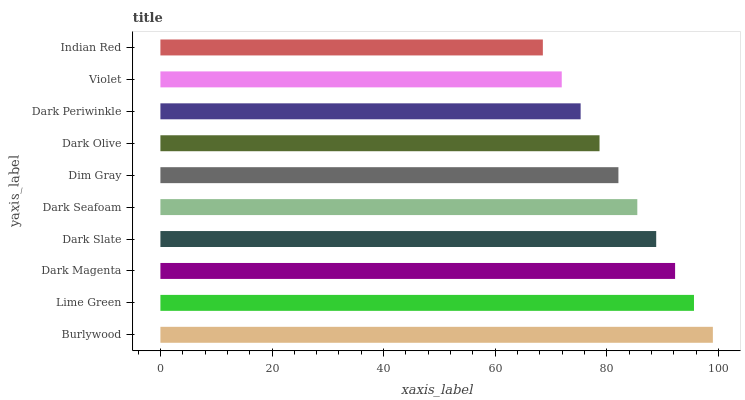Is Indian Red the minimum?
Answer yes or no. Yes. Is Burlywood the maximum?
Answer yes or no. Yes. Is Lime Green the minimum?
Answer yes or no. No. Is Lime Green the maximum?
Answer yes or no. No. Is Burlywood greater than Lime Green?
Answer yes or no. Yes. Is Lime Green less than Burlywood?
Answer yes or no. Yes. Is Lime Green greater than Burlywood?
Answer yes or no. No. Is Burlywood less than Lime Green?
Answer yes or no. No. Is Dark Seafoam the high median?
Answer yes or no. Yes. Is Dim Gray the low median?
Answer yes or no. Yes. Is Dark Periwinkle the high median?
Answer yes or no. No. Is Violet the low median?
Answer yes or no. No. 